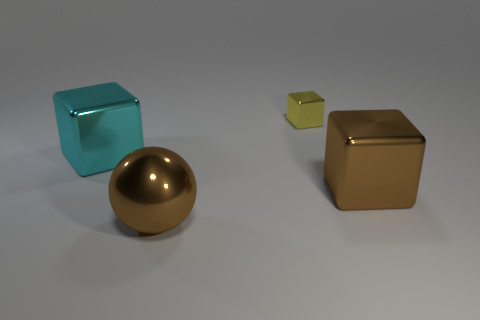Subtract all yellow cubes. How many cubes are left? 2 Add 3 tiny cyan cylinders. How many objects exist? 7 Subtract all yellow blocks. How many blocks are left? 2 Subtract all balls. How many objects are left? 3 Subtract 1 balls. How many balls are left? 0 Subtract all cyan cubes. Subtract all brown cylinders. How many cubes are left? 2 Subtract all cyan cylinders. How many brown blocks are left? 1 Subtract all tiny yellow metal things. Subtract all large things. How many objects are left? 0 Add 2 brown metallic blocks. How many brown metallic blocks are left? 3 Add 1 purple matte things. How many purple matte things exist? 1 